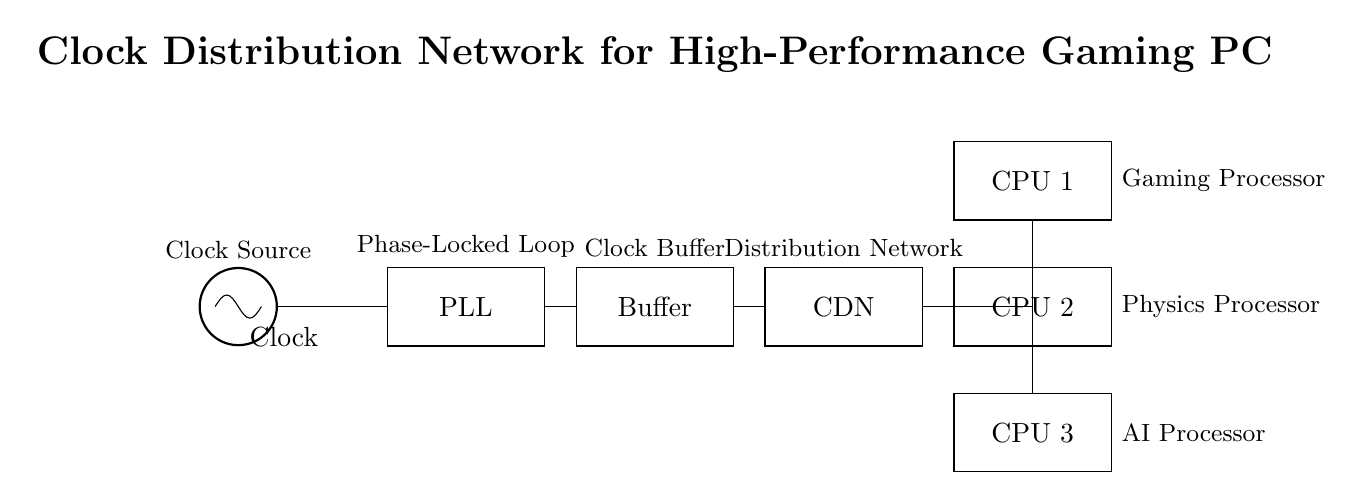What is the main function of the PLL in this circuit? The Phase-Locked Loop (PLL) stabilizes and synchronizes the clock signal to ensure all processors receive an accurate time reference.
Answer: Synchronization What is the output connection from the Buffer? The Buffer's output connects to the Clock Distribution Network (CDN), enhancing the signal strength for distribution.
Answer: CDN How many processors are synchronized by this clock distribution network? The circuit diagram shows three processors drawn, namely CPU 1, CPU 2, and CPU 3.
Answer: Three What does CDN stand for in the circuit? CDN stands for Clock Distribution Network, responsible for delivering the synchronized clock signal to multiple components.
Answer: Clock Distribution Network What is the type of each processor shown in the diagram? Each processor is designated for a specific task: CPU 1 is a gaming processor, CPU 2 is a physics processor, and CPU 3 is an AI processor.
Answer: Gaming, Physics, AI What is the purpose of using a Clock Buffer? The Clock Buffer is used to strengthen the clock signal, ensuring it can effectively drive multiple loads in the CDN without distortion.
Answer: Signal strength What does the oscillator provide in this circuit? The oscillator generates the primary clock signal that all components, including the PLL, rely on for synchronization.
Answer: Clock signal 